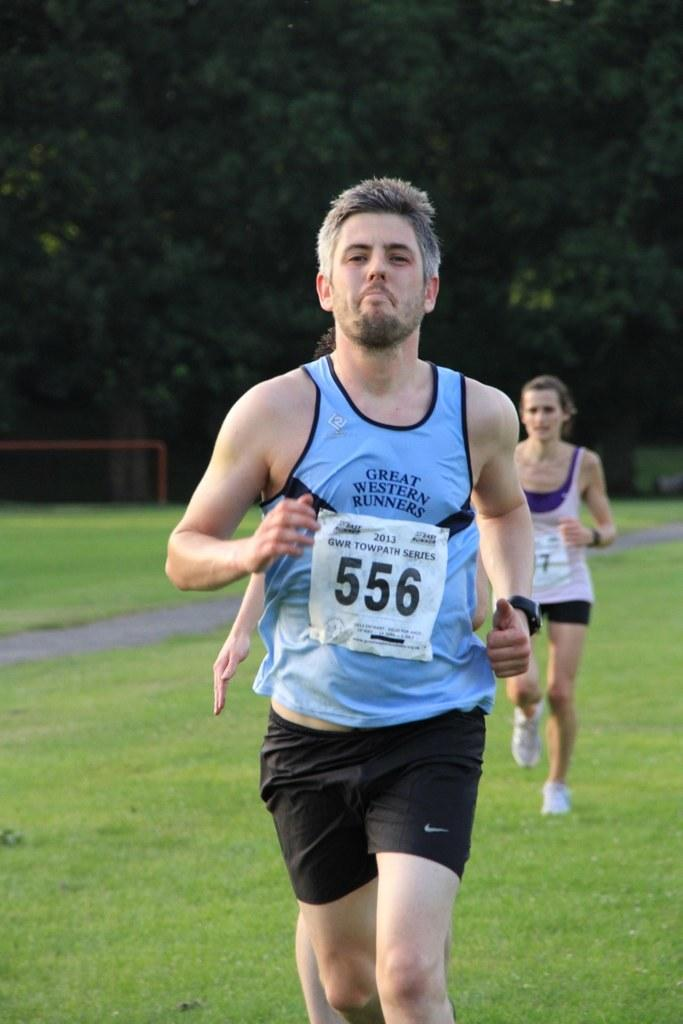<image>
Share a concise interpretation of the image provided. A man running in a marathon with identification code 556. 